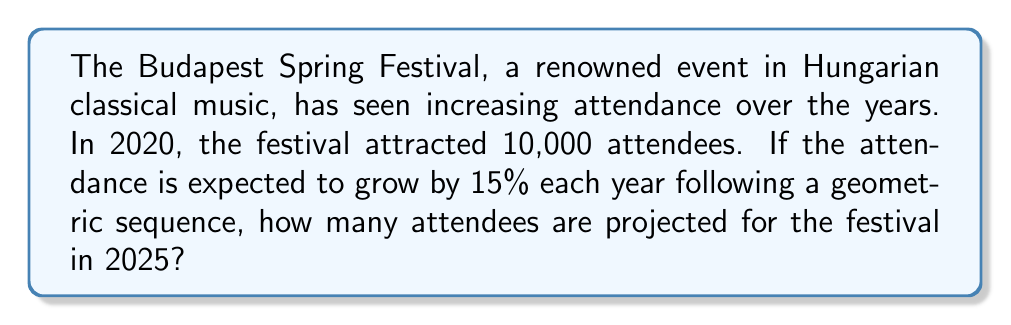Could you help me with this problem? Let's approach this step-by-step using the principles of geometric sequences:

1) The initial term (2020 attendance) is $a_1 = 10,000$

2) The common ratio is $r = 1 + 15\% = 1.15$ (since it grows by 15% each year)

3) We need to find the 6th term in the sequence (2025 is 5 years after 2020)

4) The formula for the nth term of a geometric sequence is:

   $a_n = a_1 \cdot r^{n-1}$

5) Substituting our values:

   $a_6 = 10,000 \cdot (1.15)^{6-1}$
   $a_6 = 10,000 \cdot (1.15)^5$

6) Calculate:

   $a_6 = 10,000 \cdot 2.0113689$
   $a_6 = 20,113.689$

7) Since we're dealing with people, we round down to the nearest whole number.

Therefore, the projected attendance for the 2025 Budapest Spring Festival is 20,113 people.
Answer: 20,113 attendees 